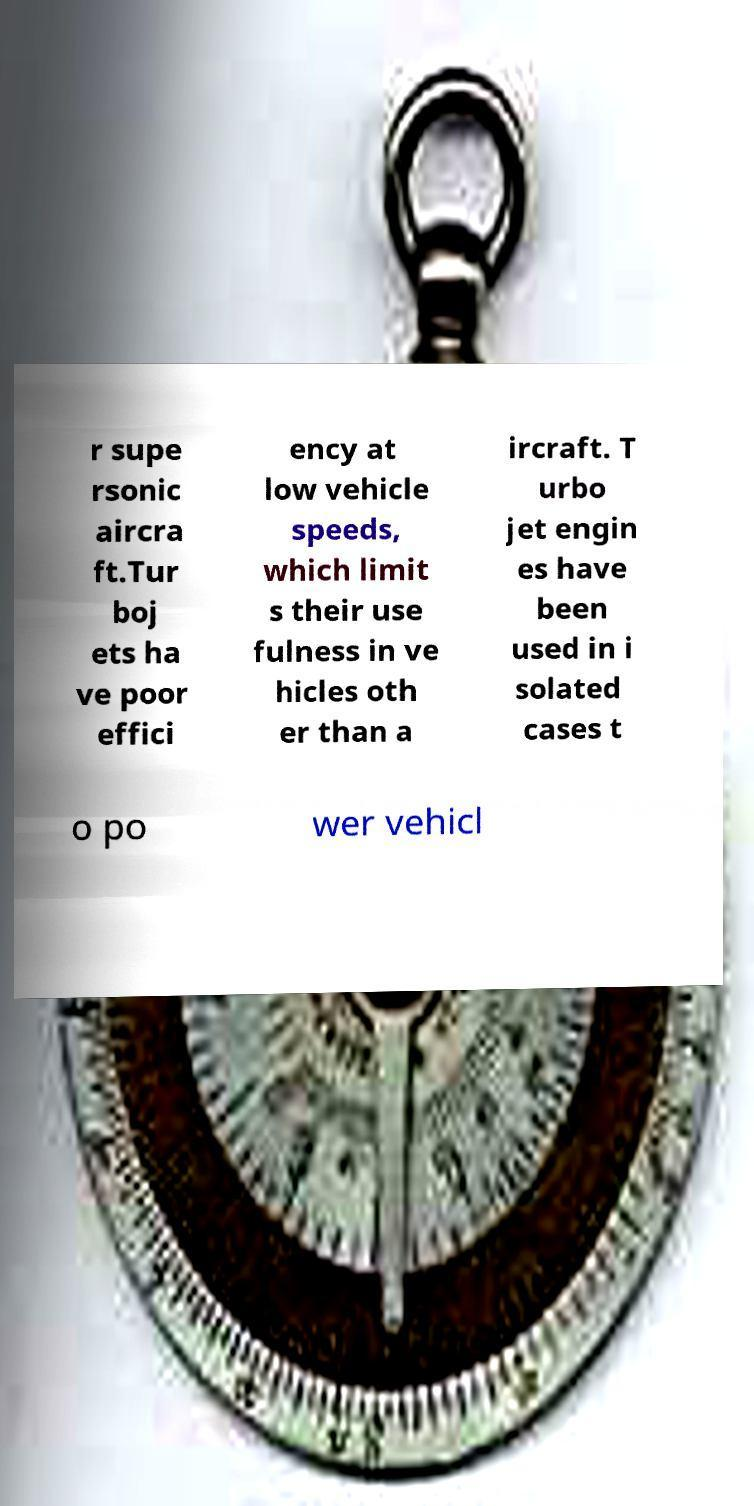I need the written content from this picture converted into text. Can you do that? r supe rsonic aircra ft.Tur boj ets ha ve poor effici ency at low vehicle speeds, which limit s their use fulness in ve hicles oth er than a ircraft. T urbo jet engin es have been used in i solated cases t o po wer vehicl 